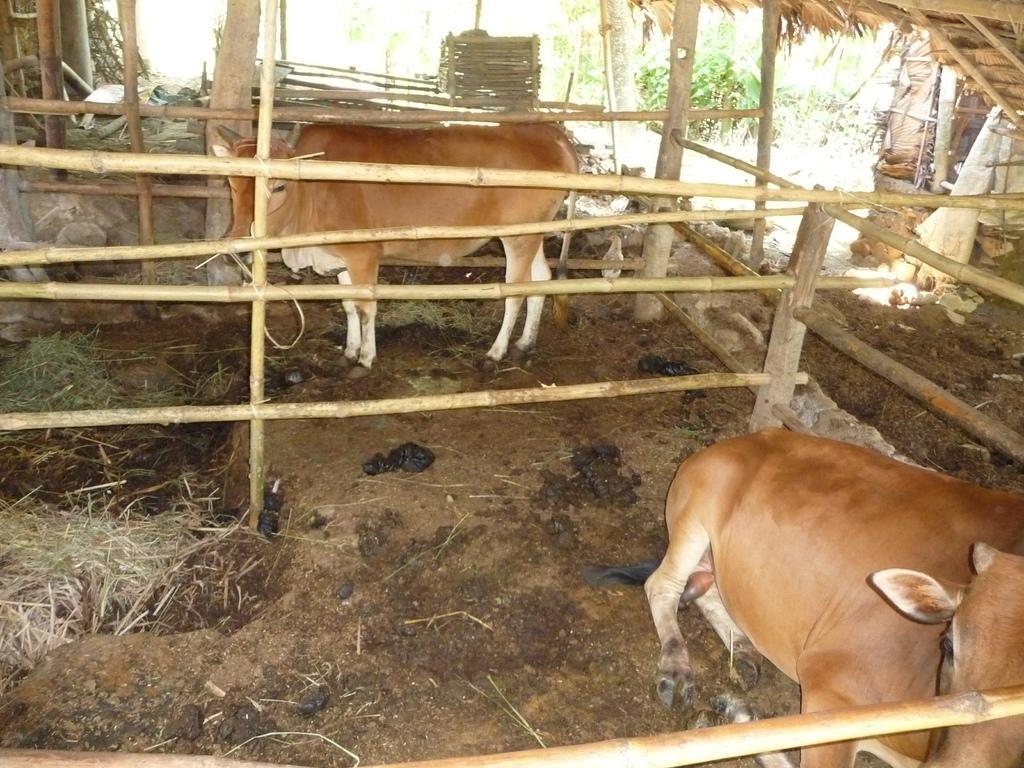In one or two sentences, can you explain what this image depicts? In this image, we can see cows on the ground. Here we can see wooden objects, plants, grass and few things. Here we can see dung on the ground. 